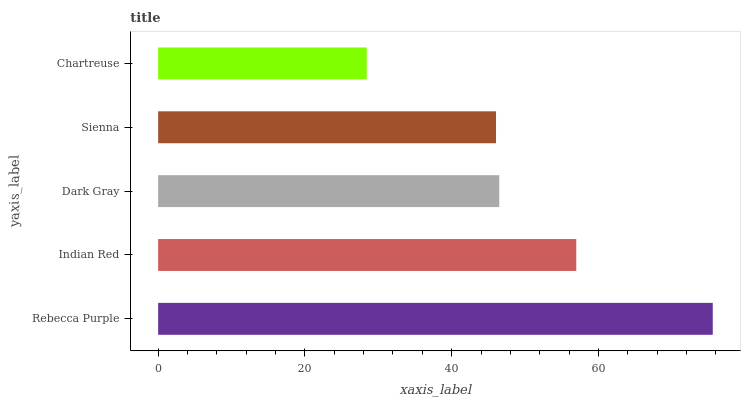Is Chartreuse the minimum?
Answer yes or no. Yes. Is Rebecca Purple the maximum?
Answer yes or no. Yes. Is Indian Red the minimum?
Answer yes or no. No. Is Indian Red the maximum?
Answer yes or no. No. Is Rebecca Purple greater than Indian Red?
Answer yes or no. Yes. Is Indian Red less than Rebecca Purple?
Answer yes or no. Yes. Is Indian Red greater than Rebecca Purple?
Answer yes or no. No. Is Rebecca Purple less than Indian Red?
Answer yes or no. No. Is Dark Gray the high median?
Answer yes or no. Yes. Is Dark Gray the low median?
Answer yes or no. Yes. Is Rebecca Purple the high median?
Answer yes or no. No. Is Chartreuse the low median?
Answer yes or no. No. 